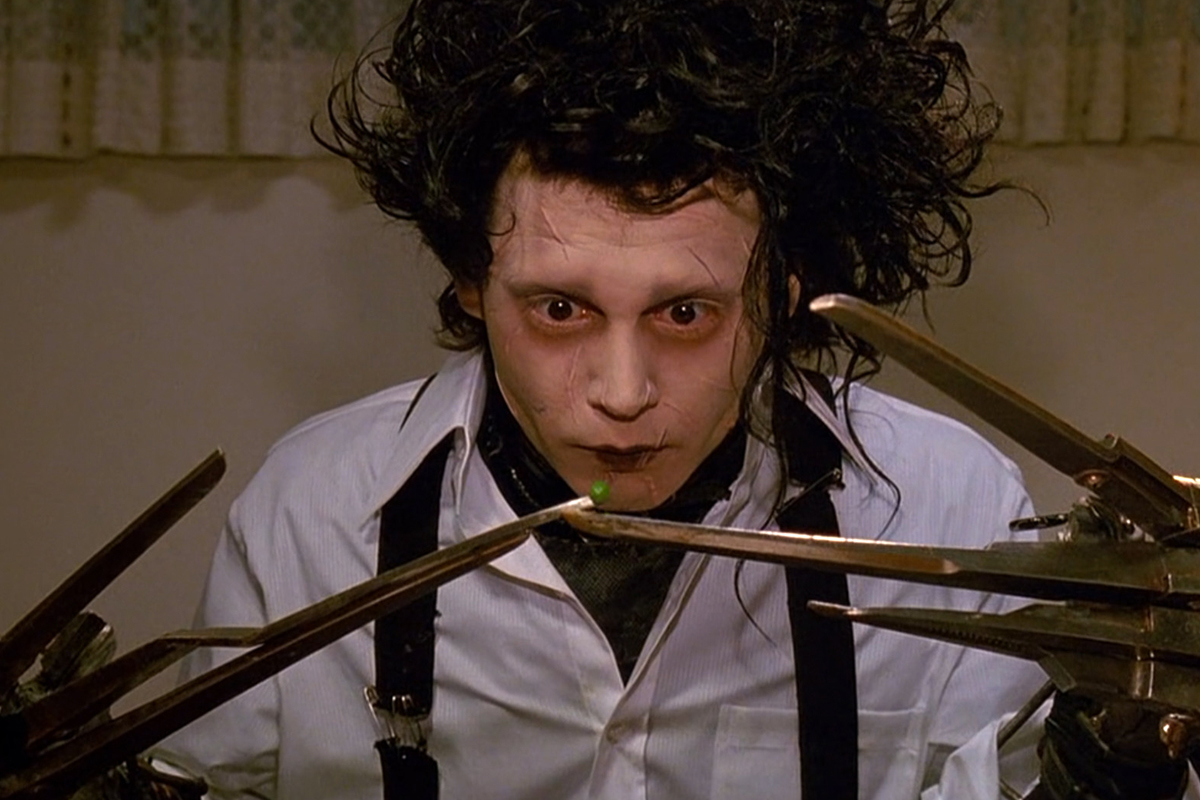What might Edward be doing if he was in a modern-day kitchen? In a modern-day kitchen, Edward might cautiously attempt to prepare a simple meal. He would meticulously slice vegetables with his scissor hands, taking great care not to damage the delicate ingredients. The sight of Edward deftly handling kitchen tasks would be a testament to his determination and adaptability, turning an ordinary activity into a demonstration of his unique skill set. Despite his unconventional tools, Edward's culinary creations would carry a touch of artistry and precision, reflecting his care and attention to detail. Can you describe how a normal day might look for Edward in today's society? A normal day for Edward in today's society would be a blend of adapting to modern conveniences and overcoming daily challenges. He might start his day with a solitary breakfast, carefully handling utensils to avoid any mishaps. Heading out, wearing his white shirt and black tie, Edward might engage in familiar activities like gardening, where his scissor hands would be incredibly useful for pruning and shaping plants into beautiful topiaries, impressing his neighbors. His quiet and kind demeanor would endear him to a few close friends who appreciate his uniqueness. In the afternoons, he might attend art classes or workshops, where his intricate scissor work would be greatly admired. Evenings could be spent indulging in hobbies like sculpture or visiting local parks to find inspiration in nature. Despite the ever-present challenges posed by his scissor hands, Edward's days would be filled with small victories and moments of quiet contentment. 